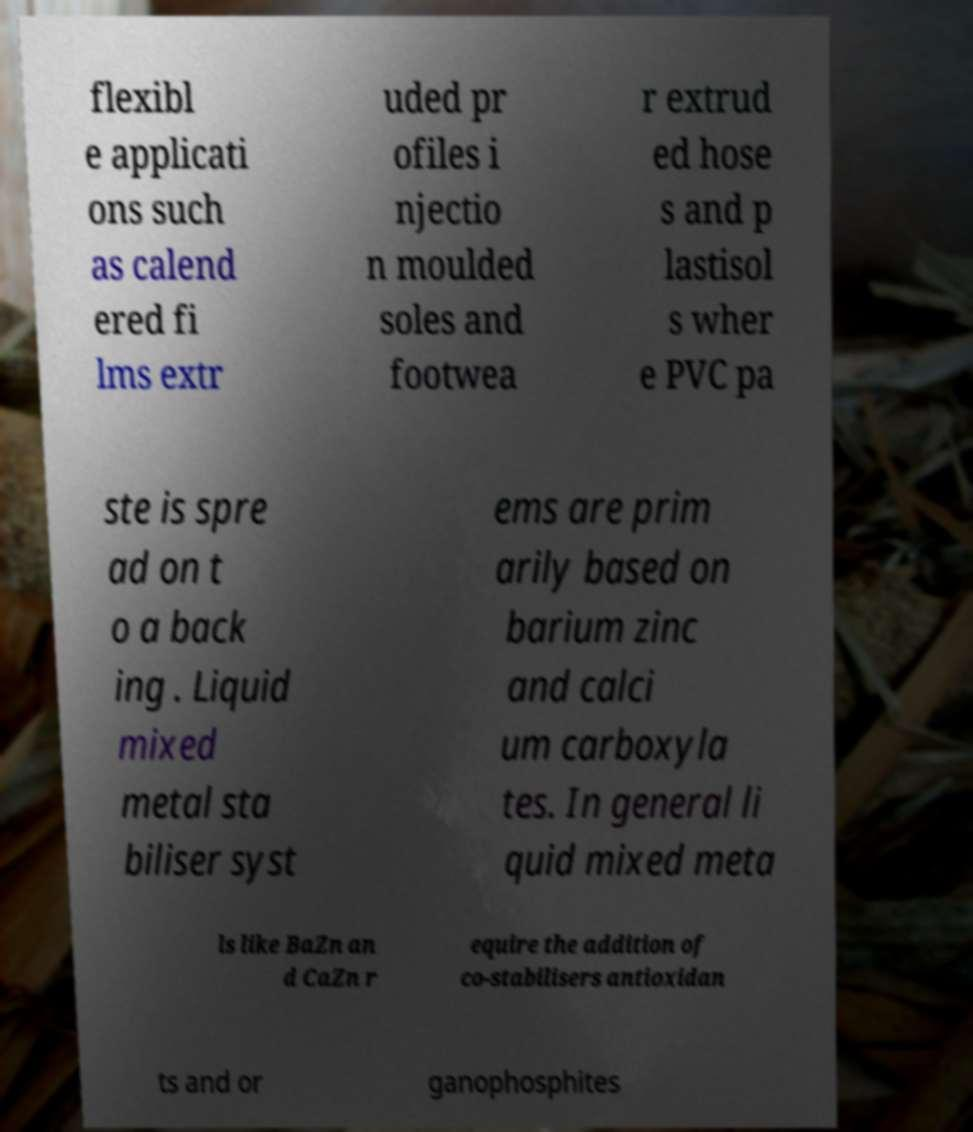For documentation purposes, I need the text within this image transcribed. Could you provide that? flexibl e applicati ons such as calend ered fi lms extr uded pr ofiles i njectio n moulded soles and footwea r extrud ed hose s and p lastisol s wher e PVC pa ste is spre ad on t o a back ing . Liquid mixed metal sta biliser syst ems are prim arily based on barium zinc and calci um carboxyla tes. In general li quid mixed meta ls like BaZn an d CaZn r equire the addition of co-stabilisers antioxidan ts and or ganophosphites 